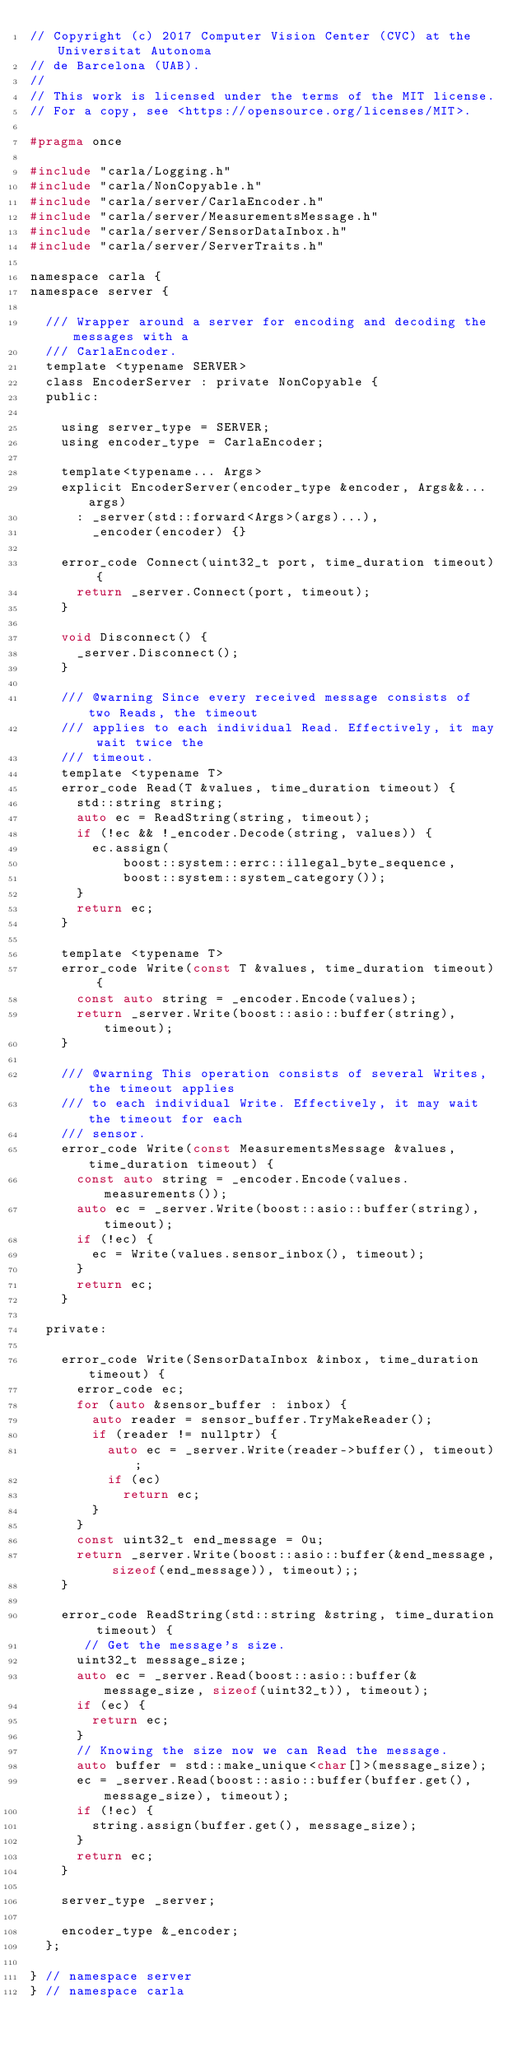Convert code to text. <code><loc_0><loc_0><loc_500><loc_500><_C_>// Copyright (c) 2017 Computer Vision Center (CVC) at the Universitat Autonoma
// de Barcelona (UAB).
//
// This work is licensed under the terms of the MIT license.
// For a copy, see <https://opensource.org/licenses/MIT>.

#pragma once

#include "carla/Logging.h"
#include "carla/NonCopyable.h"
#include "carla/server/CarlaEncoder.h"
#include "carla/server/MeasurementsMessage.h"
#include "carla/server/SensorDataInbox.h"
#include "carla/server/ServerTraits.h"

namespace carla {
namespace server {

  /// Wrapper around a server for encoding and decoding the messages with a
  /// CarlaEncoder.
  template <typename SERVER>
  class EncoderServer : private NonCopyable {
  public:

    using server_type = SERVER;
    using encoder_type = CarlaEncoder;

    template<typename... Args>
    explicit EncoderServer(encoder_type &encoder, Args&&... args)
      : _server(std::forward<Args>(args)...),
        _encoder(encoder) {}

    error_code Connect(uint32_t port, time_duration timeout) {
      return _server.Connect(port, timeout);
    }

    void Disconnect() {
      _server.Disconnect();
    }

    /// @warning Since every received message consists of two Reads, the timeout
    /// applies to each individual Read. Effectively, it may wait twice the
    /// timeout.
    template <typename T>
    error_code Read(T &values, time_duration timeout) {
      std::string string;
      auto ec = ReadString(string, timeout);
      if (!ec && !_encoder.Decode(string, values)) {
        ec.assign(
            boost::system::errc::illegal_byte_sequence,
            boost::system::system_category());
      }
      return ec;
    }

    template <typename T>
    error_code Write(const T &values, time_duration timeout) {
      const auto string = _encoder.Encode(values);
      return _server.Write(boost::asio::buffer(string), timeout);
    }

    /// @warning This operation consists of several Writes, the timeout applies
    /// to each individual Write. Effectively, it may wait the timeout for each
    /// sensor.
    error_code Write(const MeasurementsMessage &values, time_duration timeout) {
      const auto string = _encoder.Encode(values.measurements());
      auto ec = _server.Write(boost::asio::buffer(string), timeout);
      if (!ec) {
        ec = Write(values.sensor_inbox(), timeout);
      }
      return ec;
    }

  private:

    error_code Write(SensorDataInbox &inbox, time_duration timeout) {
      error_code ec;
      for (auto &sensor_buffer : inbox) {
        auto reader = sensor_buffer.TryMakeReader();
        if (reader != nullptr) {
          auto ec = _server.Write(reader->buffer(), timeout);
          if (ec)
            return ec;
        }
      }
      const uint32_t end_message = 0u;
      return _server.Write(boost::asio::buffer(&end_message, sizeof(end_message)), timeout);;
    }

    error_code ReadString(std::string &string, time_duration timeout) {
       // Get the message's size.
      uint32_t message_size;
      auto ec = _server.Read(boost::asio::buffer(&message_size, sizeof(uint32_t)), timeout);
      if (ec) {
        return ec;
      }
      // Knowing the size now we can Read the message.
      auto buffer = std::make_unique<char[]>(message_size);
      ec = _server.Read(boost::asio::buffer(buffer.get(), message_size), timeout);
      if (!ec) {
        string.assign(buffer.get(), message_size);
      }
      return ec;
    }

    server_type _server;

    encoder_type &_encoder;
  };

} // namespace server
} // namespace carla
</code> 